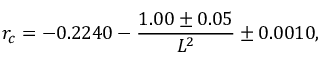Convert formula to latex. <formula><loc_0><loc_0><loc_500><loc_500>r _ { c } = - 0 . 2 2 4 0 - { \frac { 1 . 0 0 \pm 0 . 0 5 } { L ^ { 2 } } } \pm 0 . 0 0 1 0 ,</formula> 